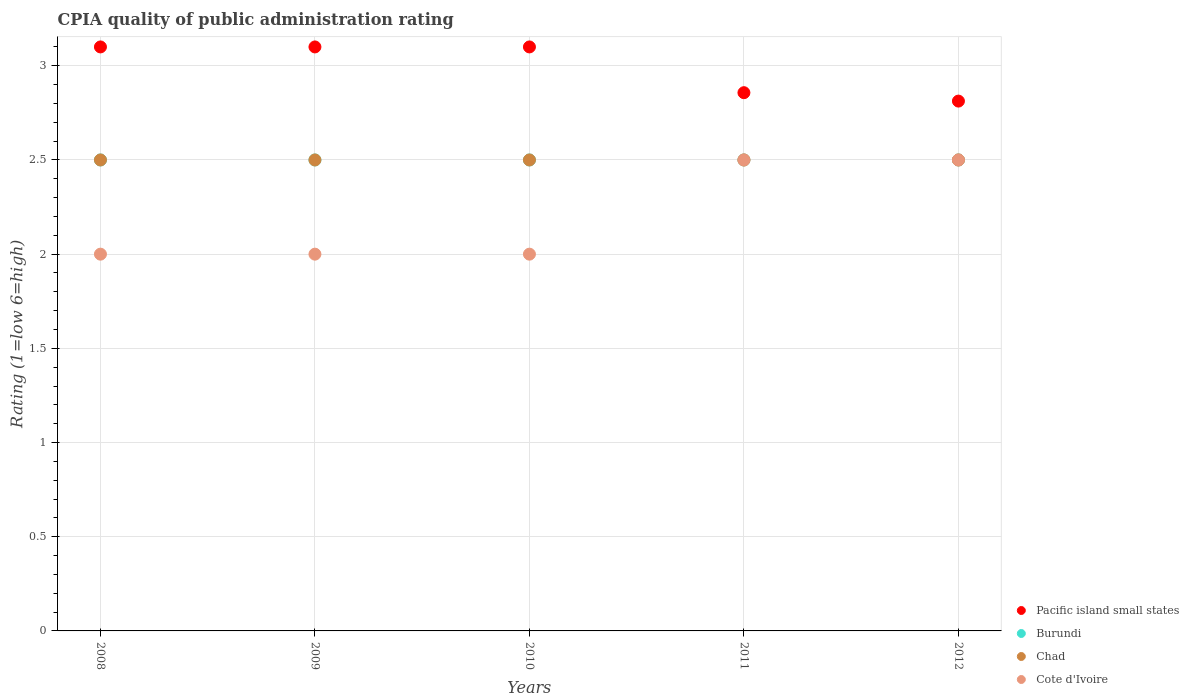How many different coloured dotlines are there?
Offer a very short reply. 4. Across all years, what is the minimum CPIA rating in Chad?
Offer a very short reply. 2.5. In which year was the CPIA rating in Chad minimum?
Your answer should be very brief. 2008. What is the total CPIA rating in Chad in the graph?
Your answer should be very brief. 12.5. What is the difference between the CPIA rating in Chad in 2008 and that in 2011?
Keep it short and to the point. 0. What is the difference between the CPIA rating in Chad in 2012 and the CPIA rating in Burundi in 2008?
Your answer should be very brief. 0. What is the average CPIA rating in Pacific island small states per year?
Provide a short and direct response. 2.99. In how many years, is the CPIA rating in Cote d'Ivoire greater than 1.8?
Make the answer very short. 5. In how many years, is the CPIA rating in Chad greater than the average CPIA rating in Chad taken over all years?
Give a very brief answer. 0. Is it the case that in every year, the sum of the CPIA rating in Pacific island small states and CPIA rating in Cote d'Ivoire  is greater than the sum of CPIA rating in Chad and CPIA rating in Burundi?
Provide a short and direct response. Yes. Is the CPIA rating in Pacific island small states strictly less than the CPIA rating in Chad over the years?
Keep it short and to the point. No. How many years are there in the graph?
Keep it short and to the point. 5. What is the title of the graph?
Your answer should be compact. CPIA quality of public administration rating. What is the label or title of the X-axis?
Offer a terse response. Years. What is the Rating (1=low 6=high) of Pacific island small states in 2009?
Keep it short and to the point. 3.1. What is the Rating (1=low 6=high) of Burundi in 2009?
Your response must be concise. 2.5. What is the Rating (1=low 6=high) in Chad in 2010?
Ensure brevity in your answer.  2.5. What is the Rating (1=low 6=high) in Pacific island small states in 2011?
Your answer should be compact. 2.86. What is the Rating (1=low 6=high) of Pacific island small states in 2012?
Ensure brevity in your answer.  2.81. What is the Rating (1=low 6=high) of Burundi in 2012?
Provide a short and direct response. 2.5. What is the Rating (1=low 6=high) in Chad in 2012?
Keep it short and to the point. 2.5. What is the Rating (1=low 6=high) in Cote d'Ivoire in 2012?
Provide a succinct answer. 2.5. Across all years, what is the maximum Rating (1=low 6=high) in Cote d'Ivoire?
Your response must be concise. 2.5. Across all years, what is the minimum Rating (1=low 6=high) of Pacific island small states?
Provide a short and direct response. 2.81. Across all years, what is the minimum Rating (1=low 6=high) of Chad?
Offer a very short reply. 2.5. What is the total Rating (1=low 6=high) in Pacific island small states in the graph?
Your answer should be compact. 14.97. What is the difference between the Rating (1=low 6=high) of Pacific island small states in 2008 and that in 2009?
Offer a very short reply. 0. What is the difference between the Rating (1=low 6=high) of Burundi in 2008 and that in 2009?
Your response must be concise. 0. What is the difference between the Rating (1=low 6=high) in Chad in 2008 and that in 2009?
Provide a short and direct response. 0. What is the difference between the Rating (1=low 6=high) in Cote d'Ivoire in 2008 and that in 2009?
Provide a succinct answer. 0. What is the difference between the Rating (1=low 6=high) of Chad in 2008 and that in 2010?
Your answer should be very brief. 0. What is the difference between the Rating (1=low 6=high) in Pacific island small states in 2008 and that in 2011?
Your response must be concise. 0.24. What is the difference between the Rating (1=low 6=high) in Chad in 2008 and that in 2011?
Provide a succinct answer. 0. What is the difference between the Rating (1=low 6=high) of Pacific island small states in 2008 and that in 2012?
Provide a succinct answer. 0.29. What is the difference between the Rating (1=low 6=high) of Burundi in 2008 and that in 2012?
Your answer should be very brief. 0. What is the difference between the Rating (1=low 6=high) in Cote d'Ivoire in 2008 and that in 2012?
Your answer should be very brief. -0.5. What is the difference between the Rating (1=low 6=high) in Burundi in 2009 and that in 2010?
Offer a terse response. 0. What is the difference between the Rating (1=low 6=high) of Pacific island small states in 2009 and that in 2011?
Your answer should be very brief. 0.24. What is the difference between the Rating (1=low 6=high) of Burundi in 2009 and that in 2011?
Provide a short and direct response. 0. What is the difference between the Rating (1=low 6=high) in Cote d'Ivoire in 2009 and that in 2011?
Provide a short and direct response. -0.5. What is the difference between the Rating (1=low 6=high) in Pacific island small states in 2009 and that in 2012?
Offer a very short reply. 0.29. What is the difference between the Rating (1=low 6=high) in Cote d'Ivoire in 2009 and that in 2012?
Keep it short and to the point. -0.5. What is the difference between the Rating (1=low 6=high) of Pacific island small states in 2010 and that in 2011?
Provide a short and direct response. 0.24. What is the difference between the Rating (1=low 6=high) in Burundi in 2010 and that in 2011?
Ensure brevity in your answer.  0. What is the difference between the Rating (1=low 6=high) of Cote d'Ivoire in 2010 and that in 2011?
Keep it short and to the point. -0.5. What is the difference between the Rating (1=low 6=high) of Pacific island small states in 2010 and that in 2012?
Your response must be concise. 0.29. What is the difference between the Rating (1=low 6=high) in Chad in 2010 and that in 2012?
Keep it short and to the point. 0. What is the difference between the Rating (1=low 6=high) of Cote d'Ivoire in 2010 and that in 2012?
Your response must be concise. -0.5. What is the difference between the Rating (1=low 6=high) in Pacific island small states in 2011 and that in 2012?
Give a very brief answer. 0.04. What is the difference between the Rating (1=low 6=high) of Burundi in 2011 and that in 2012?
Your answer should be very brief. 0. What is the difference between the Rating (1=low 6=high) of Pacific island small states in 2008 and the Rating (1=low 6=high) of Burundi in 2009?
Provide a short and direct response. 0.6. What is the difference between the Rating (1=low 6=high) in Pacific island small states in 2008 and the Rating (1=low 6=high) in Chad in 2009?
Your answer should be very brief. 0.6. What is the difference between the Rating (1=low 6=high) in Pacific island small states in 2008 and the Rating (1=low 6=high) in Cote d'Ivoire in 2009?
Keep it short and to the point. 1.1. What is the difference between the Rating (1=low 6=high) of Burundi in 2008 and the Rating (1=low 6=high) of Cote d'Ivoire in 2009?
Your response must be concise. 0.5. What is the difference between the Rating (1=low 6=high) in Pacific island small states in 2008 and the Rating (1=low 6=high) in Chad in 2010?
Give a very brief answer. 0.6. What is the difference between the Rating (1=low 6=high) in Burundi in 2008 and the Rating (1=low 6=high) in Cote d'Ivoire in 2010?
Provide a short and direct response. 0.5. What is the difference between the Rating (1=low 6=high) of Chad in 2008 and the Rating (1=low 6=high) of Cote d'Ivoire in 2010?
Offer a very short reply. 0.5. What is the difference between the Rating (1=low 6=high) in Pacific island small states in 2008 and the Rating (1=low 6=high) in Burundi in 2011?
Keep it short and to the point. 0.6. What is the difference between the Rating (1=low 6=high) in Pacific island small states in 2008 and the Rating (1=low 6=high) in Chad in 2011?
Your answer should be very brief. 0.6. What is the difference between the Rating (1=low 6=high) of Pacific island small states in 2008 and the Rating (1=low 6=high) of Cote d'Ivoire in 2011?
Keep it short and to the point. 0.6. What is the difference between the Rating (1=low 6=high) of Burundi in 2008 and the Rating (1=low 6=high) of Chad in 2011?
Provide a short and direct response. 0. What is the difference between the Rating (1=low 6=high) of Pacific island small states in 2008 and the Rating (1=low 6=high) of Chad in 2012?
Make the answer very short. 0.6. What is the difference between the Rating (1=low 6=high) in Burundi in 2008 and the Rating (1=low 6=high) in Chad in 2012?
Your answer should be compact. 0. What is the difference between the Rating (1=low 6=high) in Burundi in 2008 and the Rating (1=low 6=high) in Cote d'Ivoire in 2012?
Make the answer very short. 0. What is the difference between the Rating (1=low 6=high) in Pacific island small states in 2009 and the Rating (1=low 6=high) in Burundi in 2010?
Your response must be concise. 0.6. What is the difference between the Rating (1=low 6=high) of Pacific island small states in 2009 and the Rating (1=low 6=high) of Cote d'Ivoire in 2010?
Your response must be concise. 1.1. What is the difference between the Rating (1=low 6=high) in Burundi in 2009 and the Rating (1=low 6=high) in Chad in 2010?
Your answer should be compact. 0. What is the difference between the Rating (1=low 6=high) of Burundi in 2009 and the Rating (1=low 6=high) of Cote d'Ivoire in 2010?
Offer a very short reply. 0.5. What is the difference between the Rating (1=low 6=high) of Chad in 2009 and the Rating (1=low 6=high) of Cote d'Ivoire in 2010?
Your response must be concise. 0.5. What is the difference between the Rating (1=low 6=high) of Pacific island small states in 2009 and the Rating (1=low 6=high) of Cote d'Ivoire in 2011?
Provide a succinct answer. 0.6. What is the difference between the Rating (1=low 6=high) in Pacific island small states in 2009 and the Rating (1=low 6=high) in Burundi in 2012?
Ensure brevity in your answer.  0.6. What is the difference between the Rating (1=low 6=high) in Pacific island small states in 2009 and the Rating (1=low 6=high) in Cote d'Ivoire in 2012?
Offer a terse response. 0.6. What is the difference between the Rating (1=low 6=high) of Burundi in 2009 and the Rating (1=low 6=high) of Chad in 2012?
Your answer should be very brief. 0. What is the difference between the Rating (1=low 6=high) in Chad in 2009 and the Rating (1=low 6=high) in Cote d'Ivoire in 2012?
Provide a short and direct response. 0. What is the difference between the Rating (1=low 6=high) of Pacific island small states in 2010 and the Rating (1=low 6=high) of Burundi in 2011?
Ensure brevity in your answer.  0.6. What is the difference between the Rating (1=low 6=high) in Pacific island small states in 2010 and the Rating (1=low 6=high) in Chad in 2011?
Ensure brevity in your answer.  0.6. What is the difference between the Rating (1=low 6=high) of Pacific island small states in 2010 and the Rating (1=low 6=high) of Cote d'Ivoire in 2011?
Keep it short and to the point. 0.6. What is the difference between the Rating (1=low 6=high) of Burundi in 2010 and the Rating (1=low 6=high) of Chad in 2011?
Ensure brevity in your answer.  0. What is the difference between the Rating (1=low 6=high) in Burundi in 2010 and the Rating (1=low 6=high) in Cote d'Ivoire in 2011?
Your answer should be compact. 0. What is the difference between the Rating (1=low 6=high) of Pacific island small states in 2010 and the Rating (1=low 6=high) of Chad in 2012?
Offer a terse response. 0.6. What is the difference between the Rating (1=low 6=high) of Burundi in 2010 and the Rating (1=low 6=high) of Chad in 2012?
Offer a terse response. 0. What is the difference between the Rating (1=low 6=high) in Pacific island small states in 2011 and the Rating (1=low 6=high) in Burundi in 2012?
Offer a very short reply. 0.36. What is the difference between the Rating (1=low 6=high) of Pacific island small states in 2011 and the Rating (1=low 6=high) of Chad in 2012?
Your answer should be very brief. 0.36. What is the difference between the Rating (1=low 6=high) in Pacific island small states in 2011 and the Rating (1=low 6=high) in Cote d'Ivoire in 2012?
Make the answer very short. 0.36. What is the average Rating (1=low 6=high) of Pacific island small states per year?
Your answer should be very brief. 2.99. What is the average Rating (1=low 6=high) of Chad per year?
Provide a short and direct response. 2.5. What is the average Rating (1=low 6=high) of Cote d'Ivoire per year?
Keep it short and to the point. 2.2. In the year 2008, what is the difference between the Rating (1=low 6=high) in Pacific island small states and Rating (1=low 6=high) in Burundi?
Your response must be concise. 0.6. In the year 2008, what is the difference between the Rating (1=low 6=high) in Pacific island small states and Rating (1=low 6=high) in Cote d'Ivoire?
Your answer should be very brief. 1.1. In the year 2008, what is the difference between the Rating (1=low 6=high) in Burundi and Rating (1=low 6=high) in Chad?
Keep it short and to the point. 0. In the year 2008, what is the difference between the Rating (1=low 6=high) in Chad and Rating (1=low 6=high) in Cote d'Ivoire?
Ensure brevity in your answer.  0.5. In the year 2009, what is the difference between the Rating (1=low 6=high) in Pacific island small states and Rating (1=low 6=high) in Chad?
Offer a very short reply. 0.6. In the year 2009, what is the difference between the Rating (1=low 6=high) in Pacific island small states and Rating (1=low 6=high) in Cote d'Ivoire?
Keep it short and to the point. 1.1. In the year 2009, what is the difference between the Rating (1=low 6=high) in Burundi and Rating (1=low 6=high) in Cote d'Ivoire?
Your response must be concise. 0.5. In the year 2009, what is the difference between the Rating (1=low 6=high) in Chad and Rating (1=low 6=high) in Cote d'Ivoire?
Ensure brevity in your answer.  0.5. In the year 2010, what is the difference between the Rating (1=low 6=high) in Pacific island small states and Rating (1=low 6=high) in Chad?
Give a very brief answer. 0.6. In the year 2010, what is the difference between the Rating (1=low 6=high) in Burundi and Rating (1=low 6=high) in Chad?
Make the answer very short. 0. In the year 2011, what is the difference between the Rating (1=low 6=high) of Pacific island small states and Rating (1=low 6=high) of Burundi?
Keep it short and to the point. 0.36. In the year 2011, what is the difference between the Rating (1=low 6=high) of Pacific island small states and Rating (1=low 6=high) of Chad?
Your answer should be compact. 0.36. In the year 2011, what is the difference between the Rating (1=low 6=high) of Pacific island small states and Rating (1=low 6=high) of Cote d'Ivoire?
Ensure brevity in your answer.  0.36. In the year 2012, what is the difference between the Rating (1=low 6=high) of Pacific island small states and Rating (1=low 6=high) of Burundi?
Provide a succinct answer. 0.31. In the year 2012, what is the difference between the Rating (1=low 6=high) in Pacific island small states and Rating (1=low 6=high) in Chad?
Provide a short and direct response. 0.31. In the year 2012, what is the difference between the Rating (1=low 6=high) in Pacific island small states and Rating (1=low 6=high) in Cote d'Ivoire?
Provide a short and direct response. 0.31. What is the ratio of the Rating (1=low 6=high) of Pacific island small states in 2008 to that in 2009?
Your answer should be very brief. 1. What is the ratio of the Rating (1=low 6=high) of Burundi in 2008 to that in 2009?
Your answer should be compact. 1. What is the ratio of the Rating (1=low 6=high) of Chad in 2008 to that in 2009?
Give a very brief answer. 1. What is the ratio of the Rating (1=low 6=high) of Cote d'Ivoire in 2008 to that in 2009?
Give a very brief answer. 1. What is the ratio of the Rating (1=low 6=high) in Chad in 2008 to that in 2010?
Provide a short and direct response. 1. What is the ratio of the Rating (1=low 6=high) in Cote d'Ivoire in 2008 to that in 2010?
Make the answer very short. 1. What is the ratio of the Rating (1=low 6=high) of Pacific island small states in 2008 to that in 2011?
Make the answer very short. 1.08. What is the ratio of the Rating (1=low 6=high) in Pacific island small states in 2008 to that in 2012?
Offer a very short reply. 1.1. What is the ratio of the Rating (1=low 6=high) in Burundi in 2008 to that in 2012?
Provide a short and direct response. 1. What is the ratio of the Rating (1=low 6=high) of Pacific island small states in 2009 to that in 2010?
Your response must be concise. 1. What is the ratio of the Rating (1=low 6=high) in Burundi in 2009 to that in 2010?
Your answer should be compact. 1. What is the ratio of the Rating (1=low 6=high) of Pacific island small states in 2009 to that in 2011?
Provide a short and direct response. 1.08. What is the ratio of the Rating (1=low 6=high) of Burundi in 2009 to that in 2011?
Make the answer very short. 1. What is the ratio of the Rating (1=low 6=high) in Chad in 2009 to that in 2011?
Provide a succinct answer. 1. What is the ratio of the Rating (1=low 6=high) of Pacific island small states in 2009 to that in 2012?
Offer a terse response. 1.1. What is the ratio of the Rating (1=low 6=high) in Cote d'Ivoire in 2009 to that in 2012?
Your response must be concise. 0.8. What is the ratio of the Rating (1=low 6=high) of Pacific island small states in 2010 to that in 2011?
Offer a terse response. 1.08. What is the ratio of the Rating (1=low 6=high) of Cote d'Ivoire in 2010 to that in 2011?
Your answer should be very brief. 0.8. What is the ratio of the Rating (1=low 6=high) in Pacific island small states in 2010 to that in 2012?
Your answer should be compact. 1.1. What is the ratio of the Rating (1=low 6=high) of Chad in 2010 to that in 2012?
Provide a succinct answer. 1. What is the ratio of the Rating (1=low 6=high) in Pacific island small states in 2011 to that in 2012?
Ensure brevity in your answer.  1.02. What is the ratio of the Rating (1=low 6=high) of Chad in 2011 to that in 2012?
Your answer should be very brief. 1. What is the ratio of the Rating (1=low 6=high) in Cote d'Ivoire in 2011 to that in 2012?
Your response must be concise. 1. What is the difference between the highest and the second highest Rating (1=low 6=high) of Pacific island small states?
Offer a terse response. 0. What is the difference between the highest and the second highest Rating (1=low 6=high) of Burundi?
Make the answer very short. 0. What is the difference between the highest and the lowest Rating (1=low 6=high) of Pacific island small states?
Make the answer very short. 0.29. What is the difference between the highest and the lowest Rating (1=low 6=high) of Burundi?
Your response must be concise. 0. 